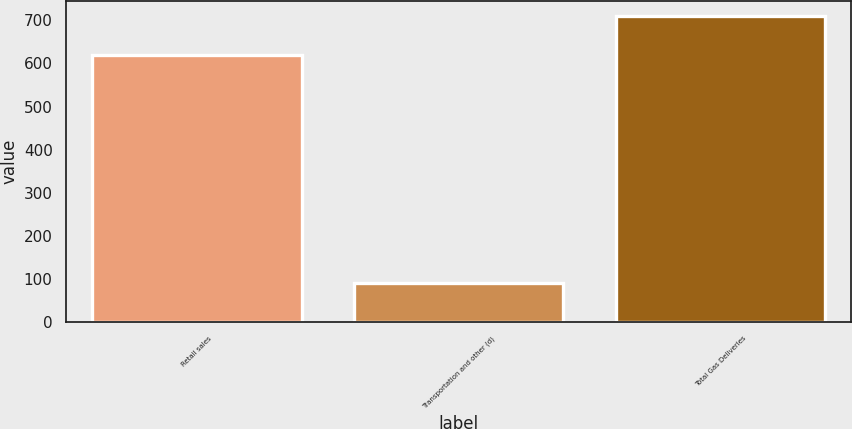<chart> <loc_0><loc_0><loc_500><loc_500><bar_chart><fcel>Retail sales<fcel>Transportation and other (d)<fcel>Total Gas Deliveries<nl><fcel>620<fcel>90<fcel>710<nl></chart> 